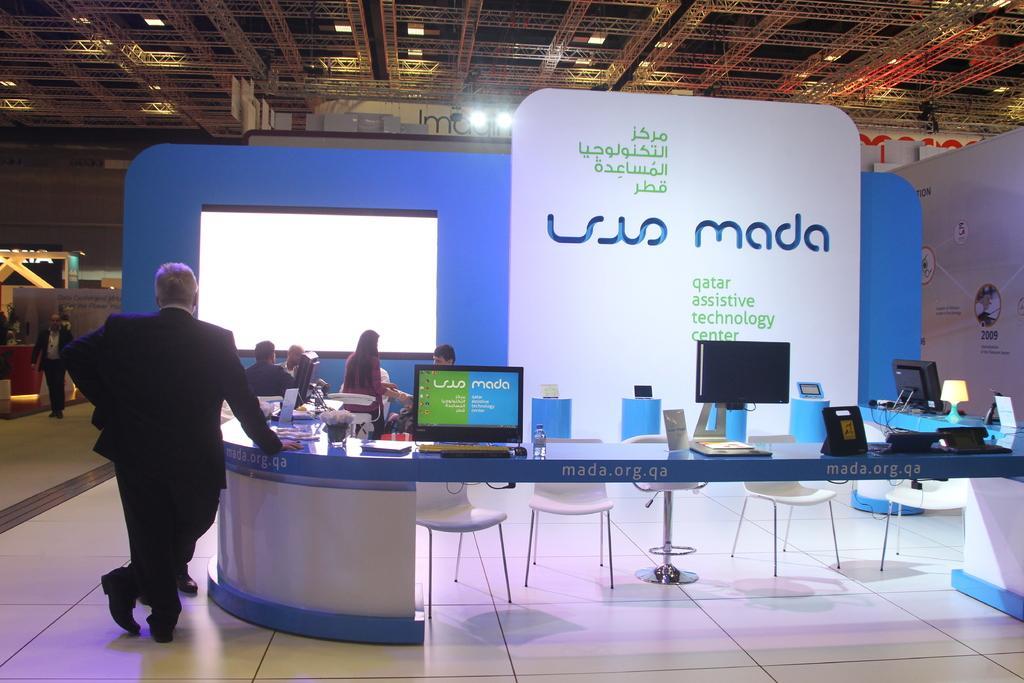Can you describe this image briefly? This picture shows a man standing and few seated and we see few monitors and few chairs 